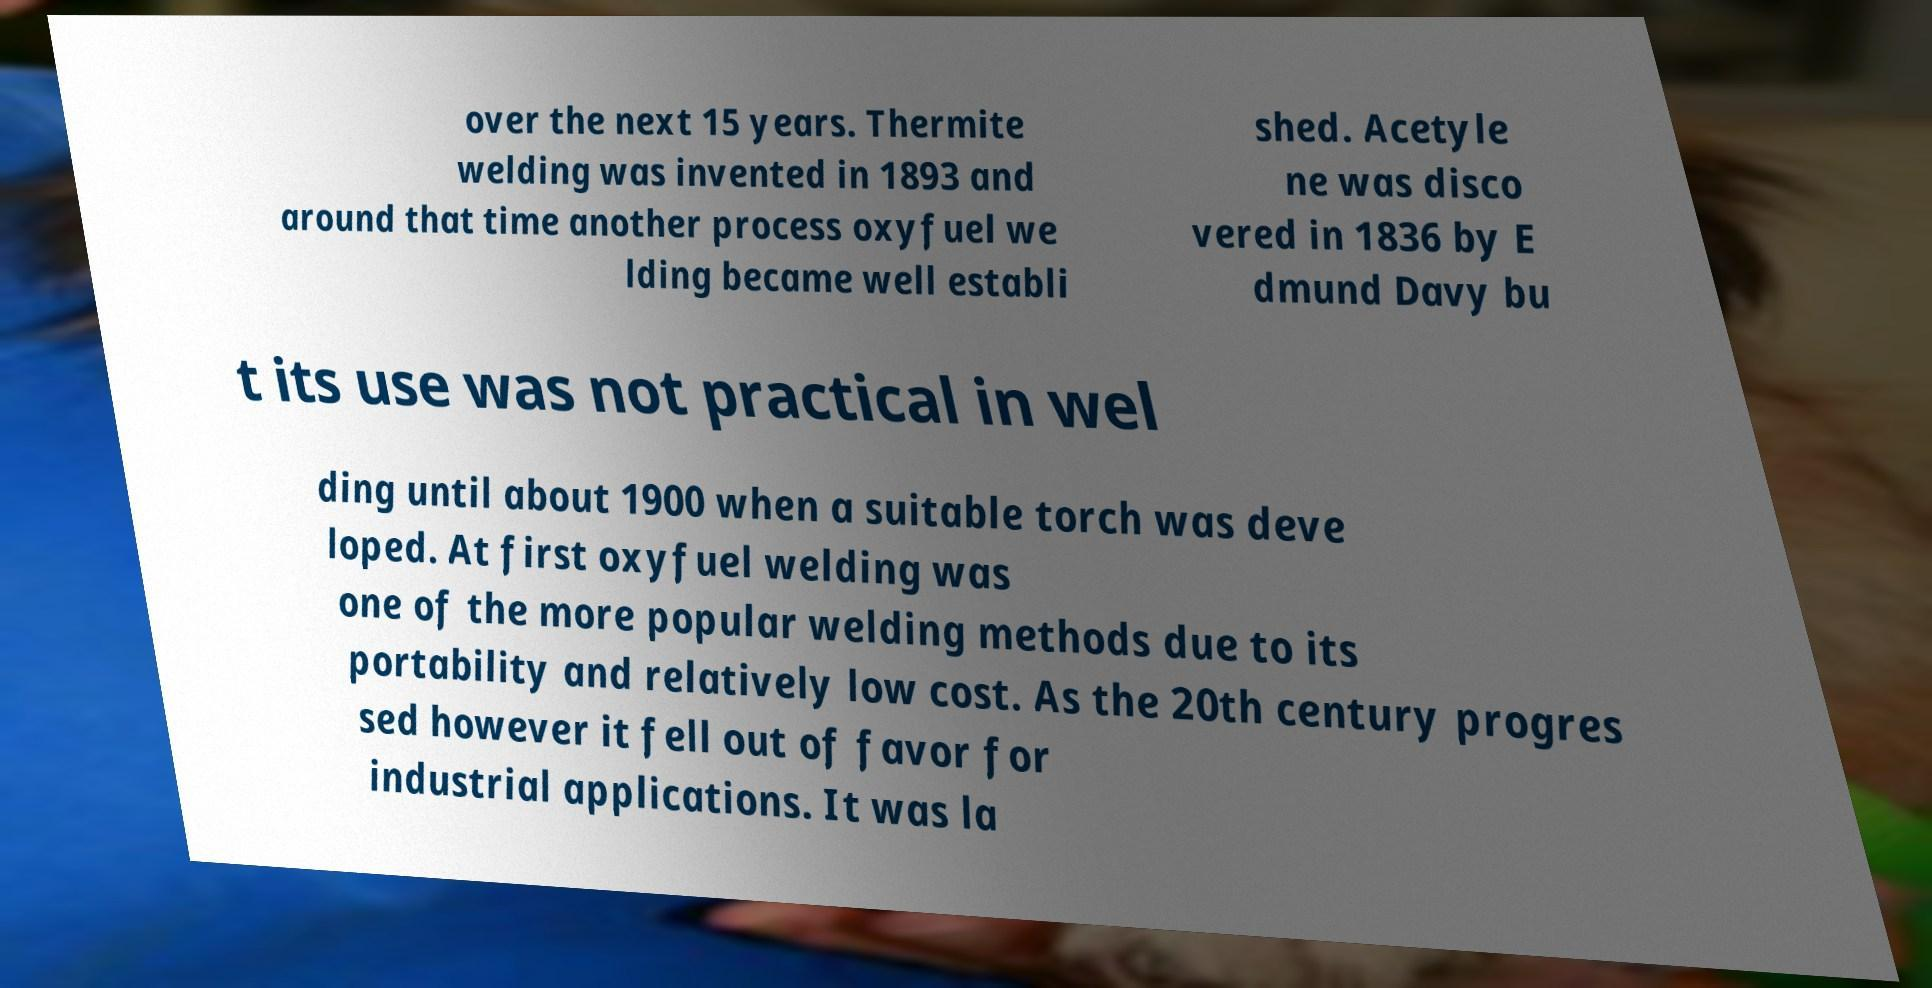Please identify and transcribe the text found in this image. over the next 15 years. Thermite welding was invented in 1893 and around that time another process oxyfuel we lding became well establi shed. Acetyle ne was disco vered in 1836 by E dmund Davy bu t its use was not practical in wel ding until about 1900 when a suitable torch was deve loped. At first oxyfuel welding was one of the more popular welding methods due to its portability and relatively low cost. As the 20th century progres sed however it fell out of favor for industrial applications. It was la 